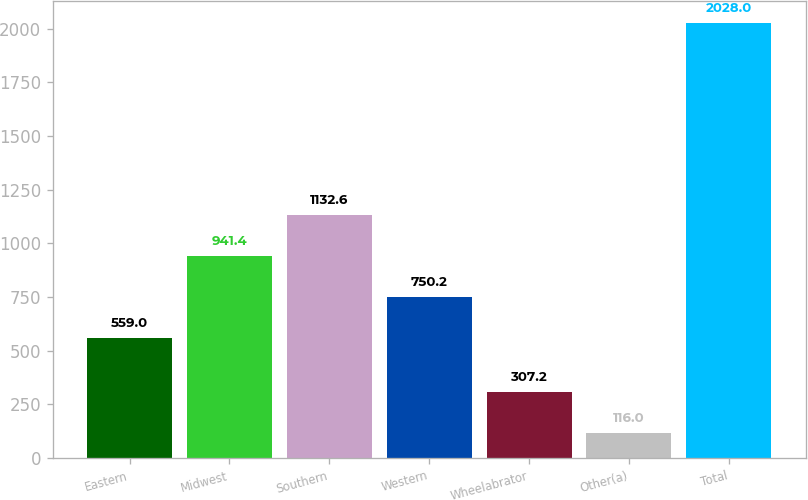Convert chart to OTSL. <chart><loc_0><loc_0><loc_500><loc_500><bar_chart><fcel>Eastern<fcel>Midwest<fcel>Southern<fcel>Western<fcel>Wheelabrator<fcel>Other(a)<fcel>Total<nl><fcel>559<fcel>941.4<fcel>1132.6<fcel>750.2<fcel>307.2<fcel>116<fcel>2028<nl></chart> 